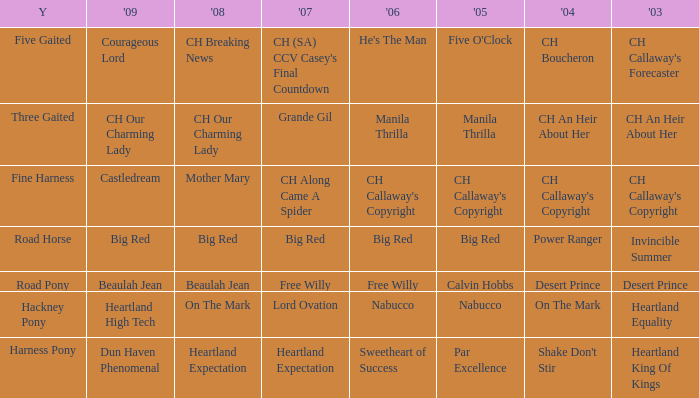What is the 2007 with ch callaway's copyright in 2003? CH Along Came A Spider. 